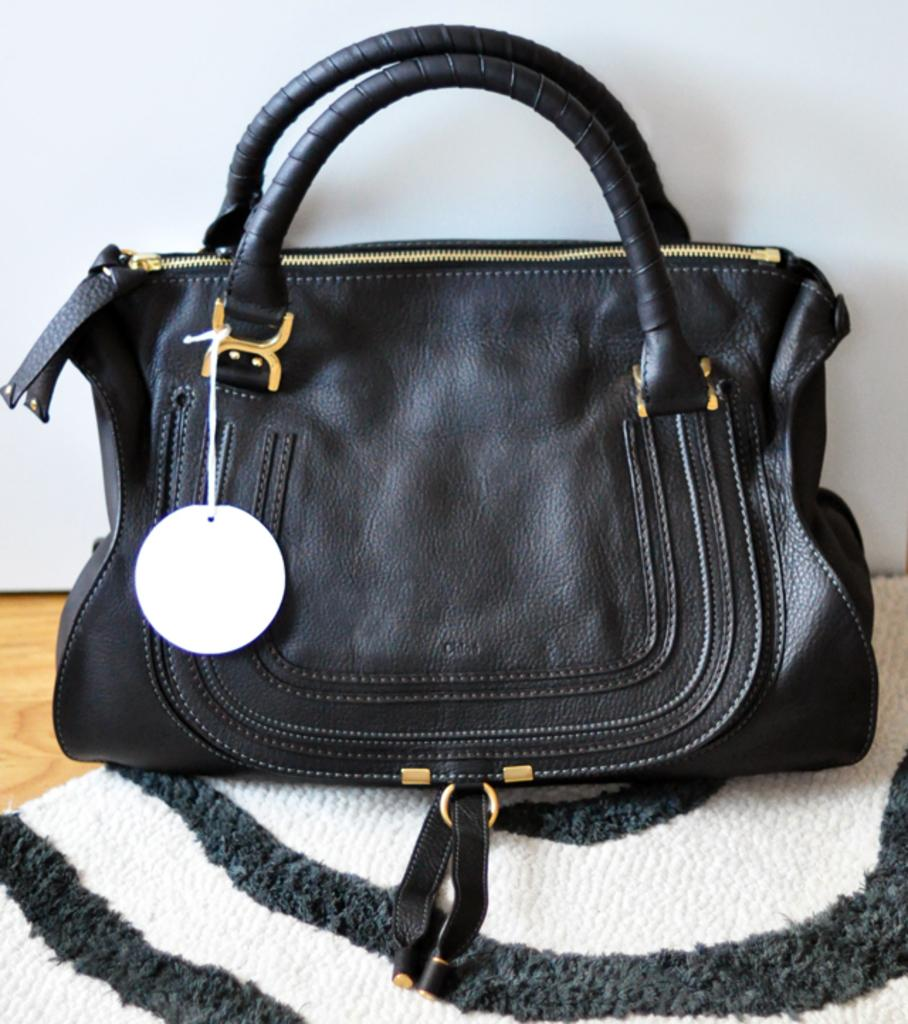What is present in the image that can be used for carrying items? There is a bag in the image that can be used for carrying items. What is the bag placed on in the image? The bag is placed on a cloth in the image. What is the color of the cloth? The cloth is black in color. What features does the bag have? The bag has zips, a tag, and a handle. What type of badge can be seen on the building in the image? There is no building or badge present in the image; it only features a bag placed on a black cloth. 